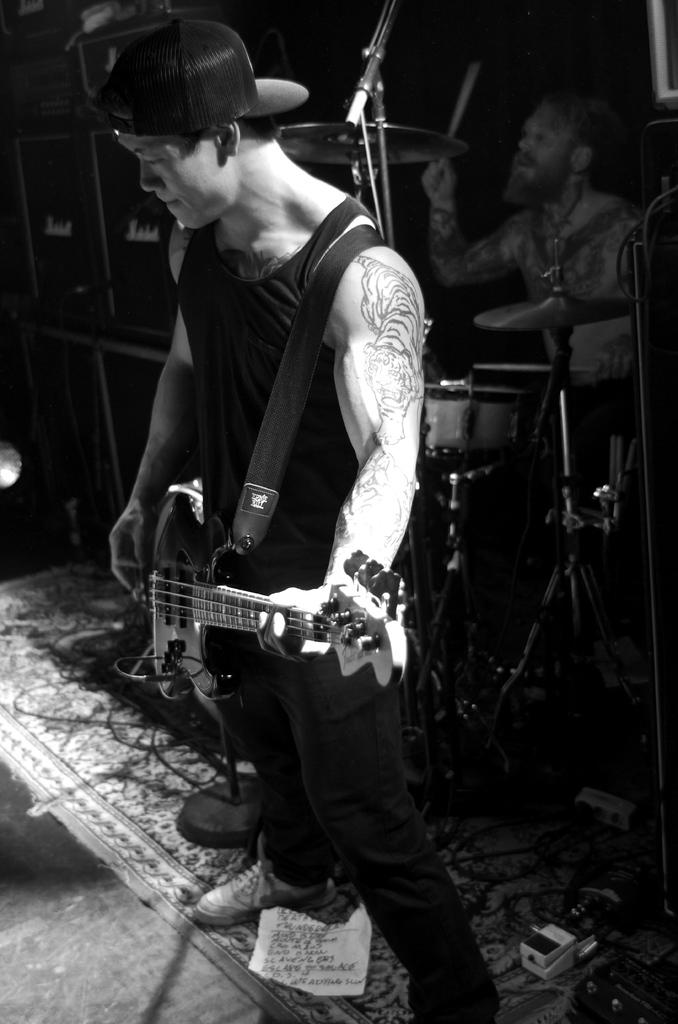What is the main subject of the image? There is a person standing in the center of the image. What is the person in the center holding? The person is holding a guitar in his hand. What can be seen in the background of the image? In the background, there is a person playing a snare drum with drumsticks. Where is the kitten playing in the image? There is no kitten present in the image. What type of spring can be seen in the image? There is no spring present in the image. 